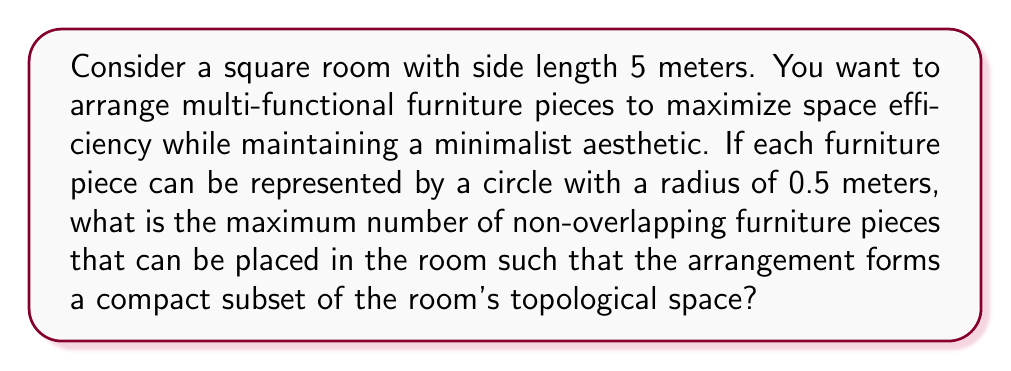Show me your answer to this math problem. To solve this problem, we need to consider the following steps:

1) First, we need to understand what compactness means in topology. A subset of a topological space is compact if every open cover has a finite subcover. In simpler terms, for our problem, it means we want to arrange the furniture pieces so that they are tightly packed without overlapping.

2) The room is a square with side length 5 meters. Its area is:

   $A_{room} = 5^2 = 25$ m²

3) Each furniture piece is represented by a circle with radius 0.5 meters. The area of each piece is:

   $A_{piece} = \pi r^2 = \pi (0.5)^2 = 0.25\pi$ m²

4) To maximize the number of pieces while maintaining compactness, we need to consider the densest packing of circles in a plane. The densest packing of circles covers approximately 90.69% of the plane's area.

5) Therefore, the maximum area that can be covered by furniture pieces is:

   $A_{covered} = 0.9069 \times 25 = 22.6725$ m²

6) The number of furniture pieces that can fit in this area is:

   $N = \frac{A_{covered}}{A_{piece}} = \frac{22.6725}{0.25\pi} \approx 28.95$

7) Since we can only have whole pieces of furniture, we round down to 28.

8) To verify compactness, we can visualize the arrangement:

   [asy]
   import geometry;

   size(200);
   
   draw(box((0,0),(5,5)));
   
   real r = 0.5;
   pair[] centers = {
     (0.5,0.5), (1.5,0.5), (2.5,0.5), (3.5,0.5), (4.5,0.5),
     (1,1.37), (2,1.37), (3,1.37), (4,1.37),
     (0.5,2.24), (1.5,2.24), (2.5,2.24), (3.5,2.24), (4.5,2.24),
     (1,3.11), (2,3.11), (3,3.11), (4,3.11),
     (0.5,3.98), (1.5,3.98), (2.5,3.98), (3.5,3.98), (4.5,3.98),
     (1,4.85), (2,4.85), (3,4.85), (4,4.85)
   };
   
   for(pair c : centers) {
     draw(circle(c, r));
   }
   [/asy]

This arrangement forms a compact subset of the room's topological space, as it maximizes the use of available area while maintaining the required spacing between furniture pieces.
Answer: The maximum number of non-overlapping furniture pieces that can be placed in the room to form a compact subset is 28. 